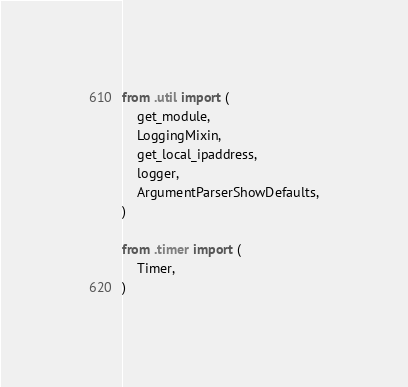Convert code to text. <code><loc_0><loc_0><loc_500><loc_500><_Python_>from .util import (
    get_module,
    LoggingMixin,
    get_local_ipaddress,
    logger,
    ArgumentParserShowDefaults,
)

from .timer import (
    Timer,
)
</code> 